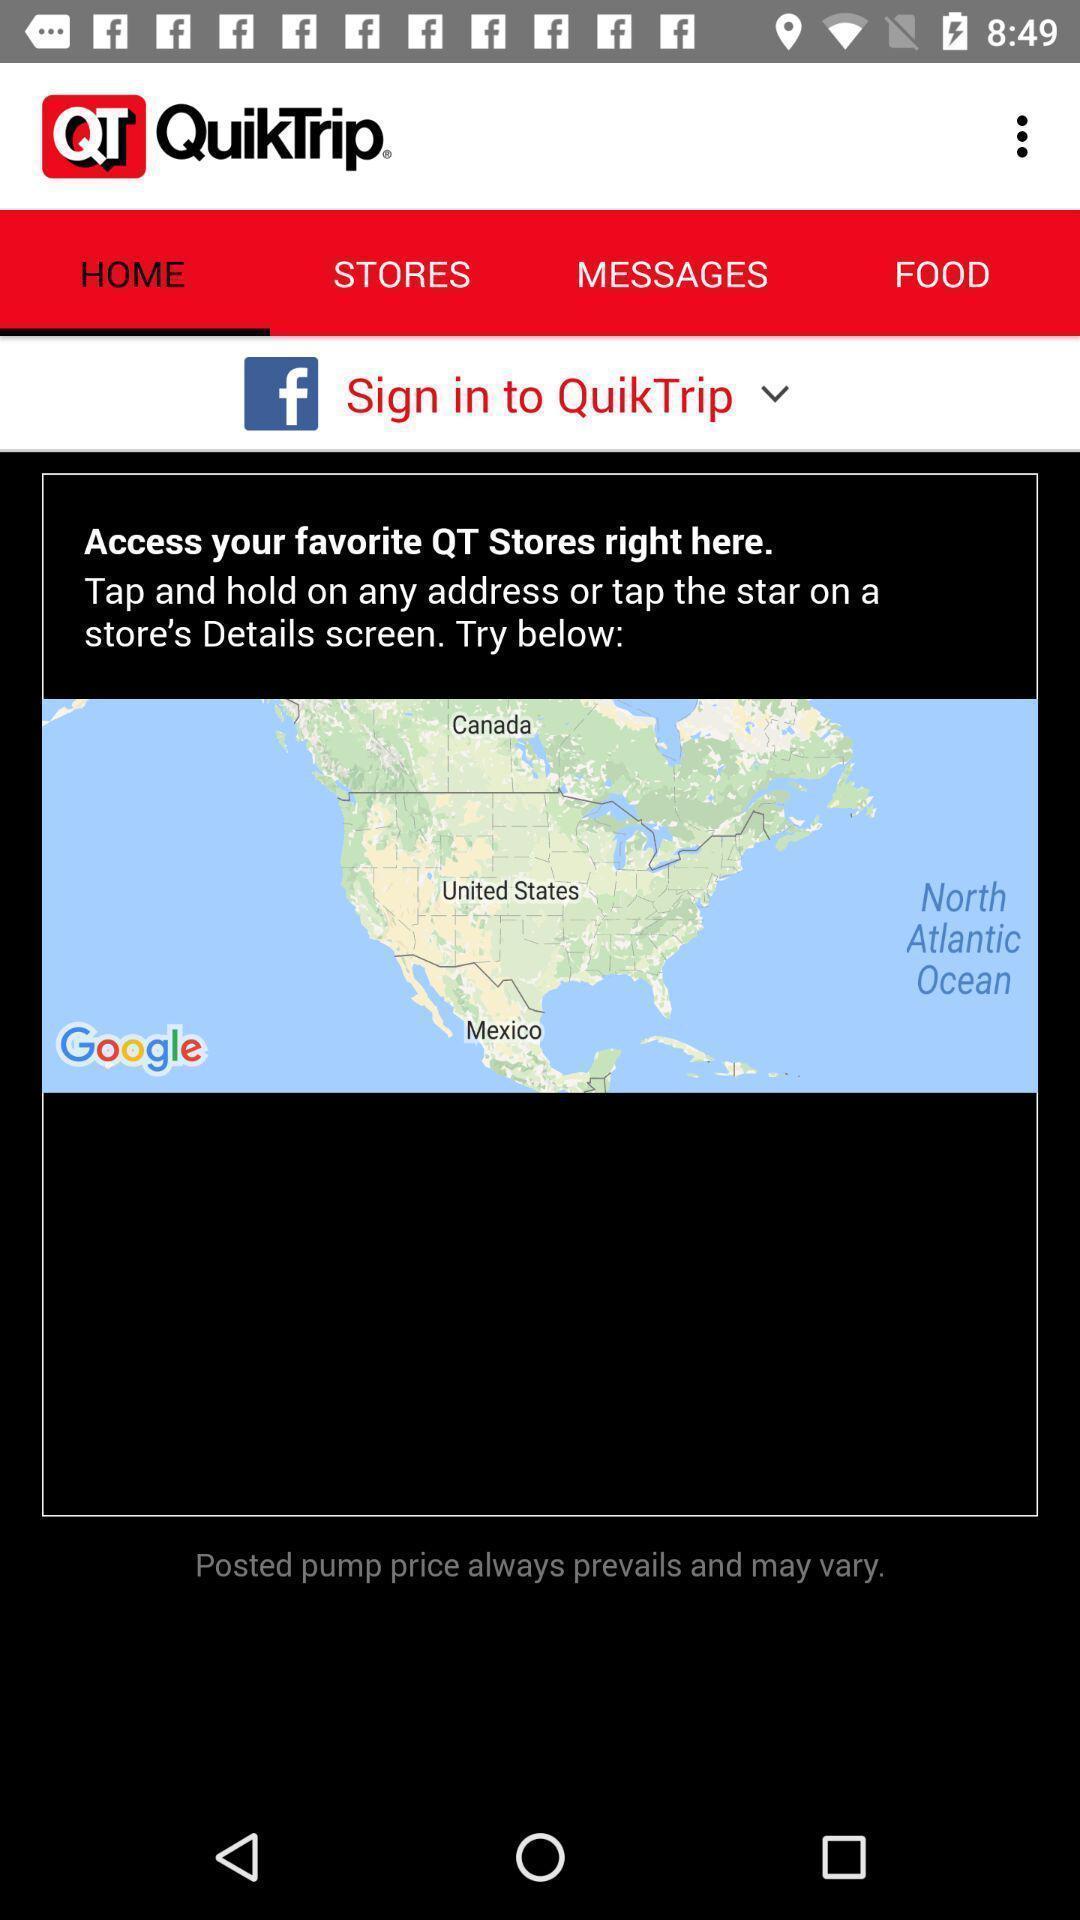Describe the key features of this screenshot. Screen showing sign in to application. 